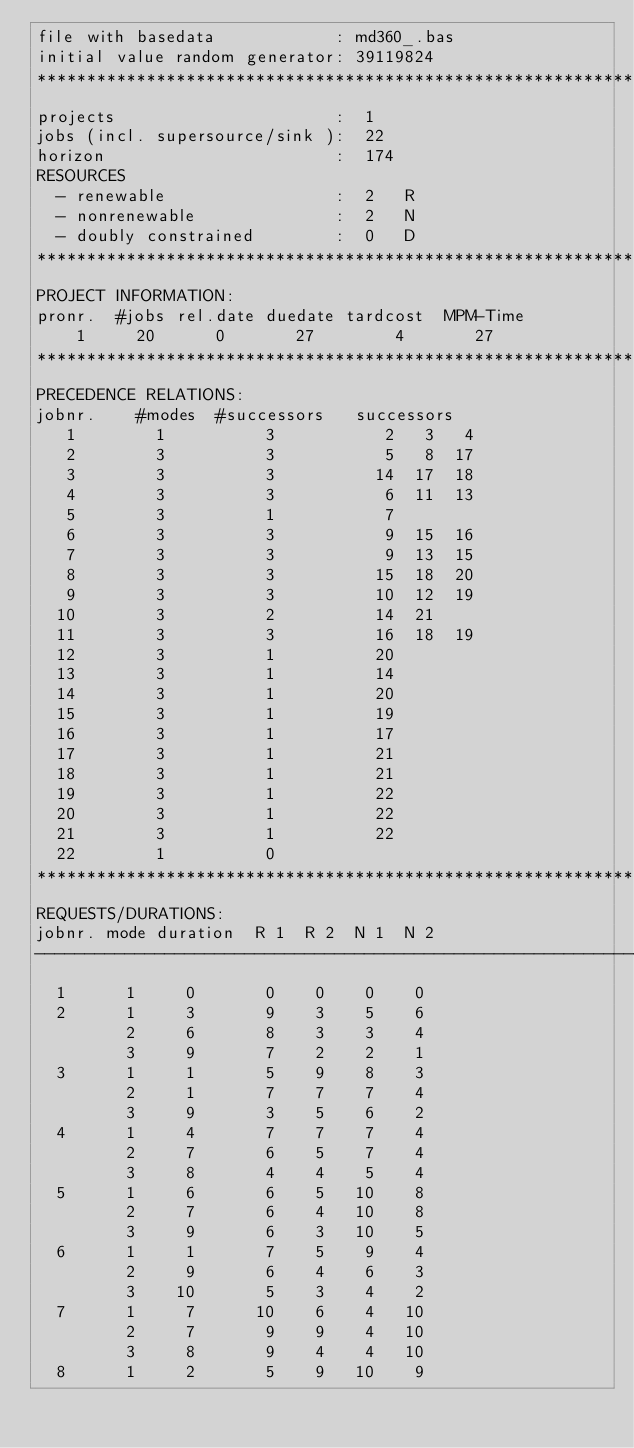<code> <loc_0><loc_0><loc_500><loc_500><_ObjectiveC_>file with basedata            : md360_.bas
initial value random generator: 39119824
************************************************************************
projects                      :  1
jobs (incl. supersource/sink ):  22
horizon                       :  174
RESOURCES
  - renewable                 :  2   R
  - nonrenewable              :  2   N
  - doubly constrained        :  0   D
************************************************************************
PROJECT INFORMATION:
pronr.  #jobs rel.date duedate tardcost  MPM-Time
    1     20      0       27        4       27
************************************************************************
PRECEDENCE RELATIONS:
jobnr.    #modes  #successors   successors
   1        1          3           2   3   4
   2        3          3           5   8  17
   3        3          3          14  17  18
   4        3          3           6  11  13
   5        3          1           7
   6        3          3           9  15  16
   7        3          3           9  13  15
   8        3          3          15  18  20
   9        3          3          10  12  19
  10        3          2          14  21
  11        3          3          16  18  19
  12        3          1          20
  13        3          1          14
  14        3          1          20
  15        3          1          19
  16        3          1          17
  17        3          1          21
  18        3          1          21
  19        3          1          22
  20        3          1          22
  21        3          1          22
  22        1          0        
************************************************************************
REQUESTS/DURATIONS:
jobnr. mode duration  R 1  R 2  N 1  N 2
------------------------------------------------------------------------
  1      1     0       0    0    0    0
  2      1     3       9    3    5    6
         2     6       8    3    3    4
         3     9       7    2    2    1
  3      1     1       5    9    8    3
         2     1       7    7    7    4
         3     9       3    5    6    2
  4      1     4       7    7    7    4
         2     7       6    5    7    4
         3     8       4    4    5    4
  5      1     6       6    5   10    8
         2     7       6    4   10    8
         3     9       6    3   10    5
  6      1     1       7    5    9    4
         2     9       6    4    6    3
         3    10       5    3    4    2
  7      1     7      10    6    4   10
         2     7       9    9    4   10
         3     8       9    4    4   10
  8      1     2       5    9   10    9</code> 